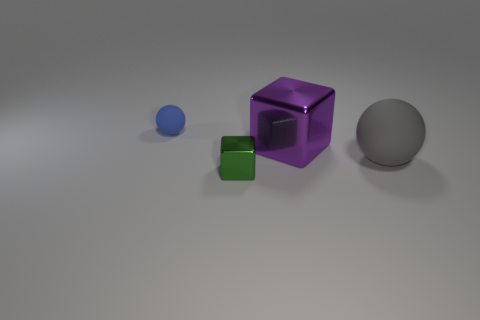Add 3 big red balls. How many objects exist? 7 Add 4 tiny metal cubes. How many tiny metal cubes exist? 5 Subtract 0 green cylinders. How many objects are left? 4 Subtract all big cyan rubber objects. Subtract all large purple objects. How many objects are left? 3 Add 1 blue objects. How many blue objects are left? 2 